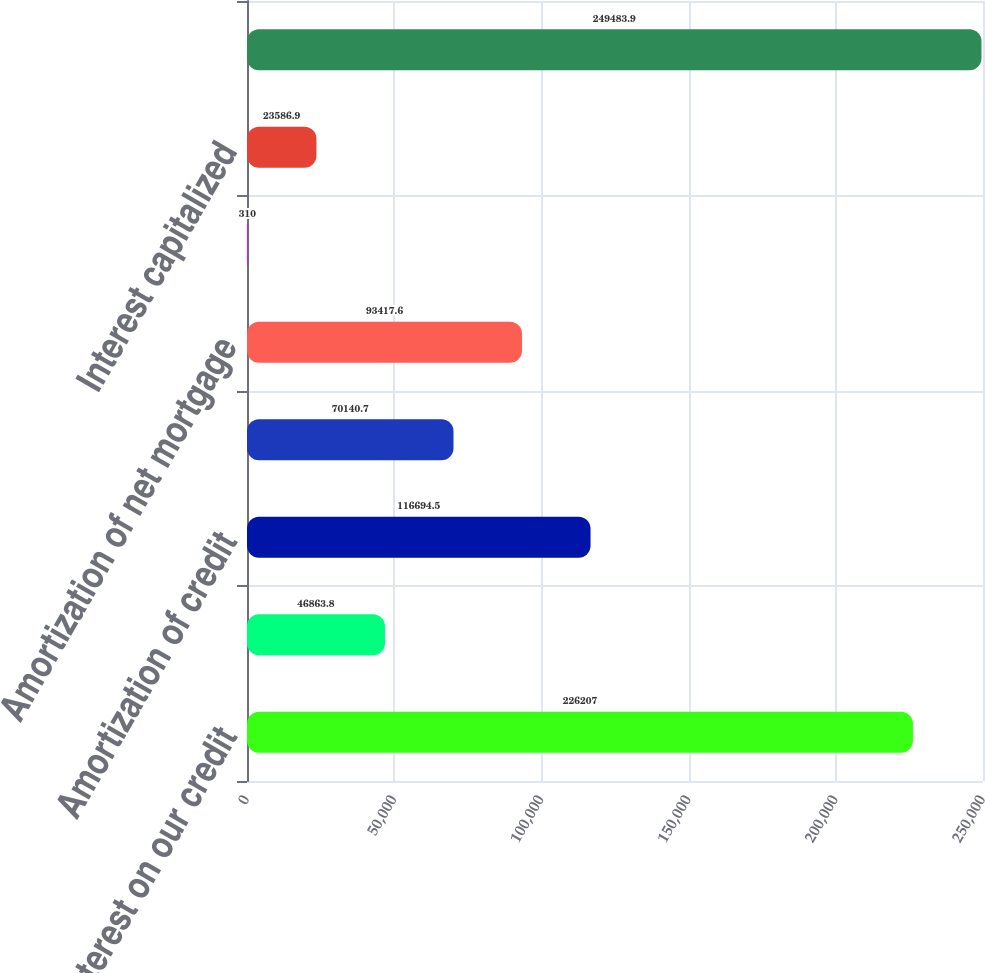Convert chart. <chart><loc_0><loc_0><loc_500><loc_500><bar_chart><fcel>Interest on our credit<fcel>Credit facility commitment<fcel>Amortization of credit<fcel>(Gain) loss on interest rate<fcel>Amortization of net mortgage<fcel>Capital lease obligation<fcel>Interest capitalized<fcel>Interest expense<nl><fcel>226207<fcel>46863.8<fcel>116694<fcel>70140.7<fcel>93417.6<fcel>310<fcel>23586.9<fcel>249484<nl></chart> 